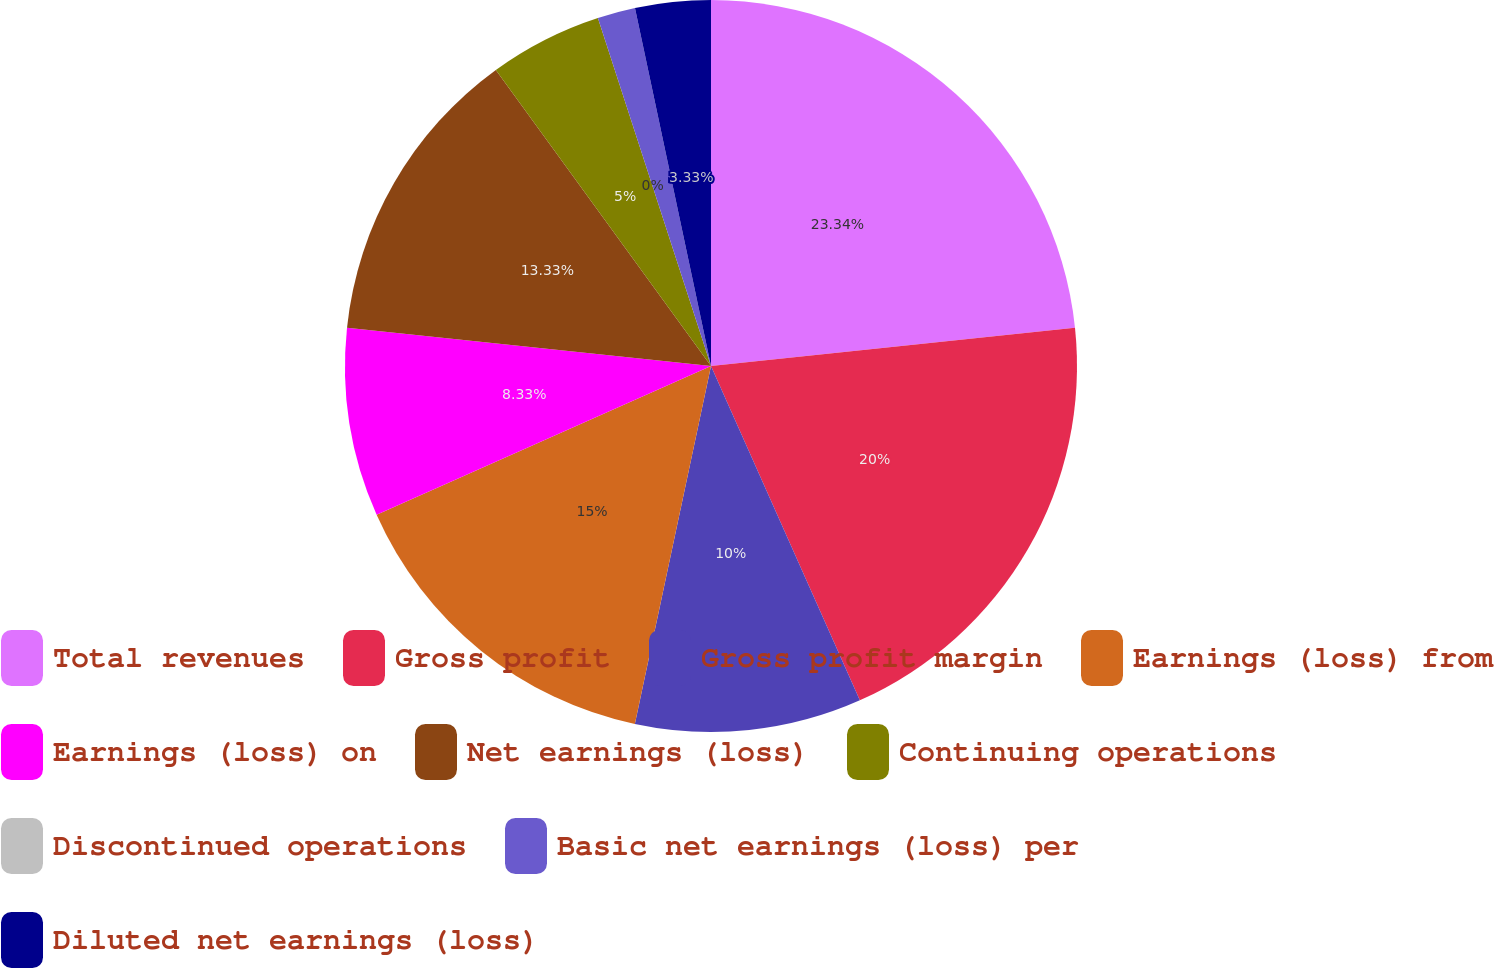Convert chart to OTSL. <chart><loc_0><loc_0><loc_500><loc_500><pie_chart><fcel>Total revenues<fcel>Gross profit<fcel>Gross profit margin<fcel>Earnings (loss) from<fcel>Earnings (loss) on<fcel>Net earnings (loss)<fcel>Continuing operations<fcel>Discontinued operations<fcel>Basic net earnings (loss) per<fcel>Diluted net earnings (loss)<nl><fcel>23.33%<fcel>20.0%<fcel>10.0%<fcel>15.0%<fcel>8.33%<fcel>13.33%<fcel>5.0%<fcel>0.0%<fcel>1.67%<fcel>3.33%<nl></chart> 